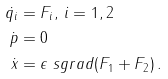Convert formula to latex. <formula><loc_0><loc_0><loc_500><loc_500>\dot { q _ { i } } & = F _ { i } , \, i = 1 , 2 \\ \dot { p } & = 0 \\ \dot { x } & = \epsilon \ s g r a d ( F _ { 1 } + F _ { 2 } ) \, .</formula> 